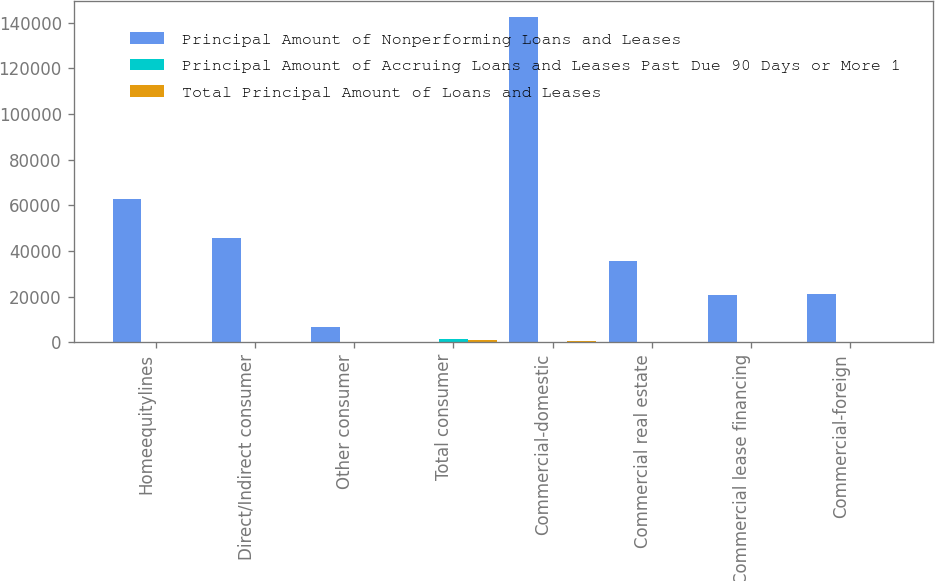<chart> <loc_0><loc_0><loc_500><loc_500><stacked_bar_chart><ecel><fcel>Homeequitylines<fcel>Direct/Indirect consumer<fcel>Other consumer<fcel>Total consumer<fcel>Commercial-domestic<fcel>Commercial real estate<fcel>Commercial lease financing<fcel>Commercial-foreign<nl><fcel>Principal Amount of Nonperforming Loans and Leases<fcel>62553<fcel>45490<fcel>6725<fcel>117<fcel>142437<fcel>35766<fcel>20705<fcel>21330<nl><fcel>Principal Amount of Accruing Loans and Leases Past Due 90 Days or More 1<fcel>3<fcel>75<fcel>15<fcel>1310<fcel>117<fcel>4<fcel>15<fcel>32<nl><fcel>Total Principal Amount of Loans and Leases<fcel>117<fcel>37<fcel>61<fcel>785<fcel>581<fcel>49<fcel>62<fcel>34<nl></chart> 